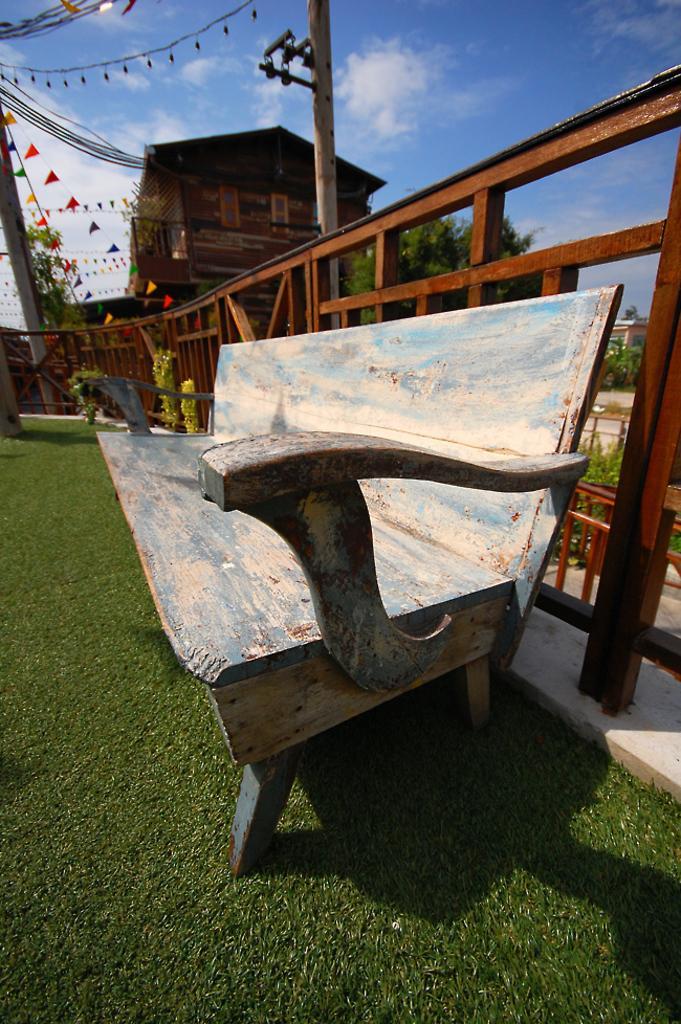Could you give a brief overview of what you see in this image? In the center of the image there is a bench on the grass. In the background we can see poles, wooden fencing, building, trees, sky and clouds. 